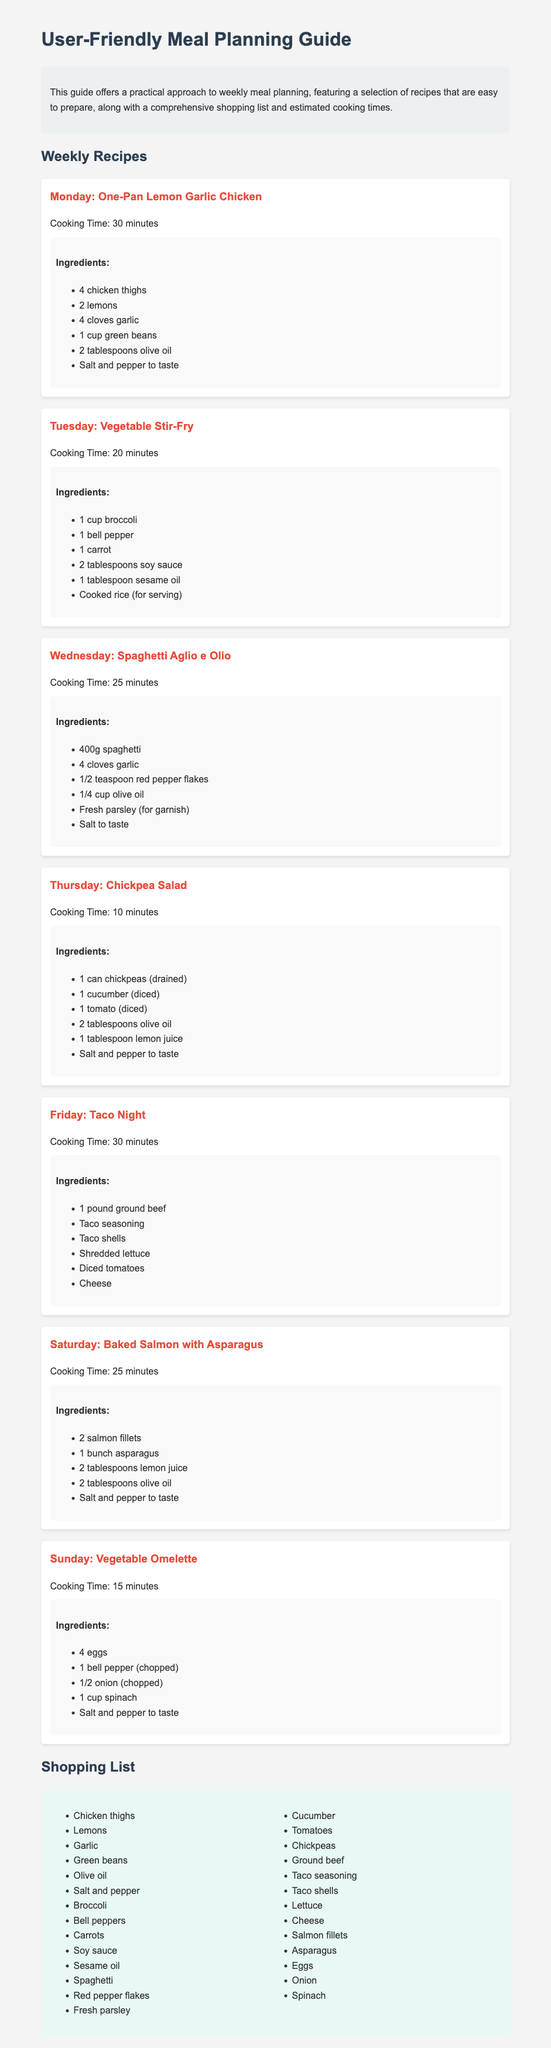What is the cooking time for Monday's recipe? The cooking time for Monday's recipe, One-Pan Lemon Garlic Chicken, is listed in the recipe information section.
Answer: 30 minutes How many recipes are included in the guide? The number of recipes can be determined by counting the recipes listed under the Weekly Recipes section.
Answer: 7 recipes What is an ingredient in Tuesday's Vegetable Stir-Fry? One of the ingredients listed for Tuesday's recipe can be found in the Ingredients section of that recipe.
Answer: Broccoli Which day features Taco Night? The day for Taco Night is mentioned in the title of the corresponding recipe.
Answer: Friday How long does it take to prepare the Chickpea Salad? The cooking time is provided in the recipe information section for Chickpea Salad.
Answer: 10 minutes What ingredient is needed for the Spaghetti Aglio e Olio? An ingredient for the Spaghetti Aglio e Olio can be found in the Ingredients list of that specific recipe.
Answer: Spaghetti What is the main protein in Saturday's recipe? The main protein can be identified from the title and ingredients of Saturday's recipe.
Answer: Salmon fillets How many items are on the shopping list? The total number of items can be counted from the Shopping List section.
Answer: 25 items 